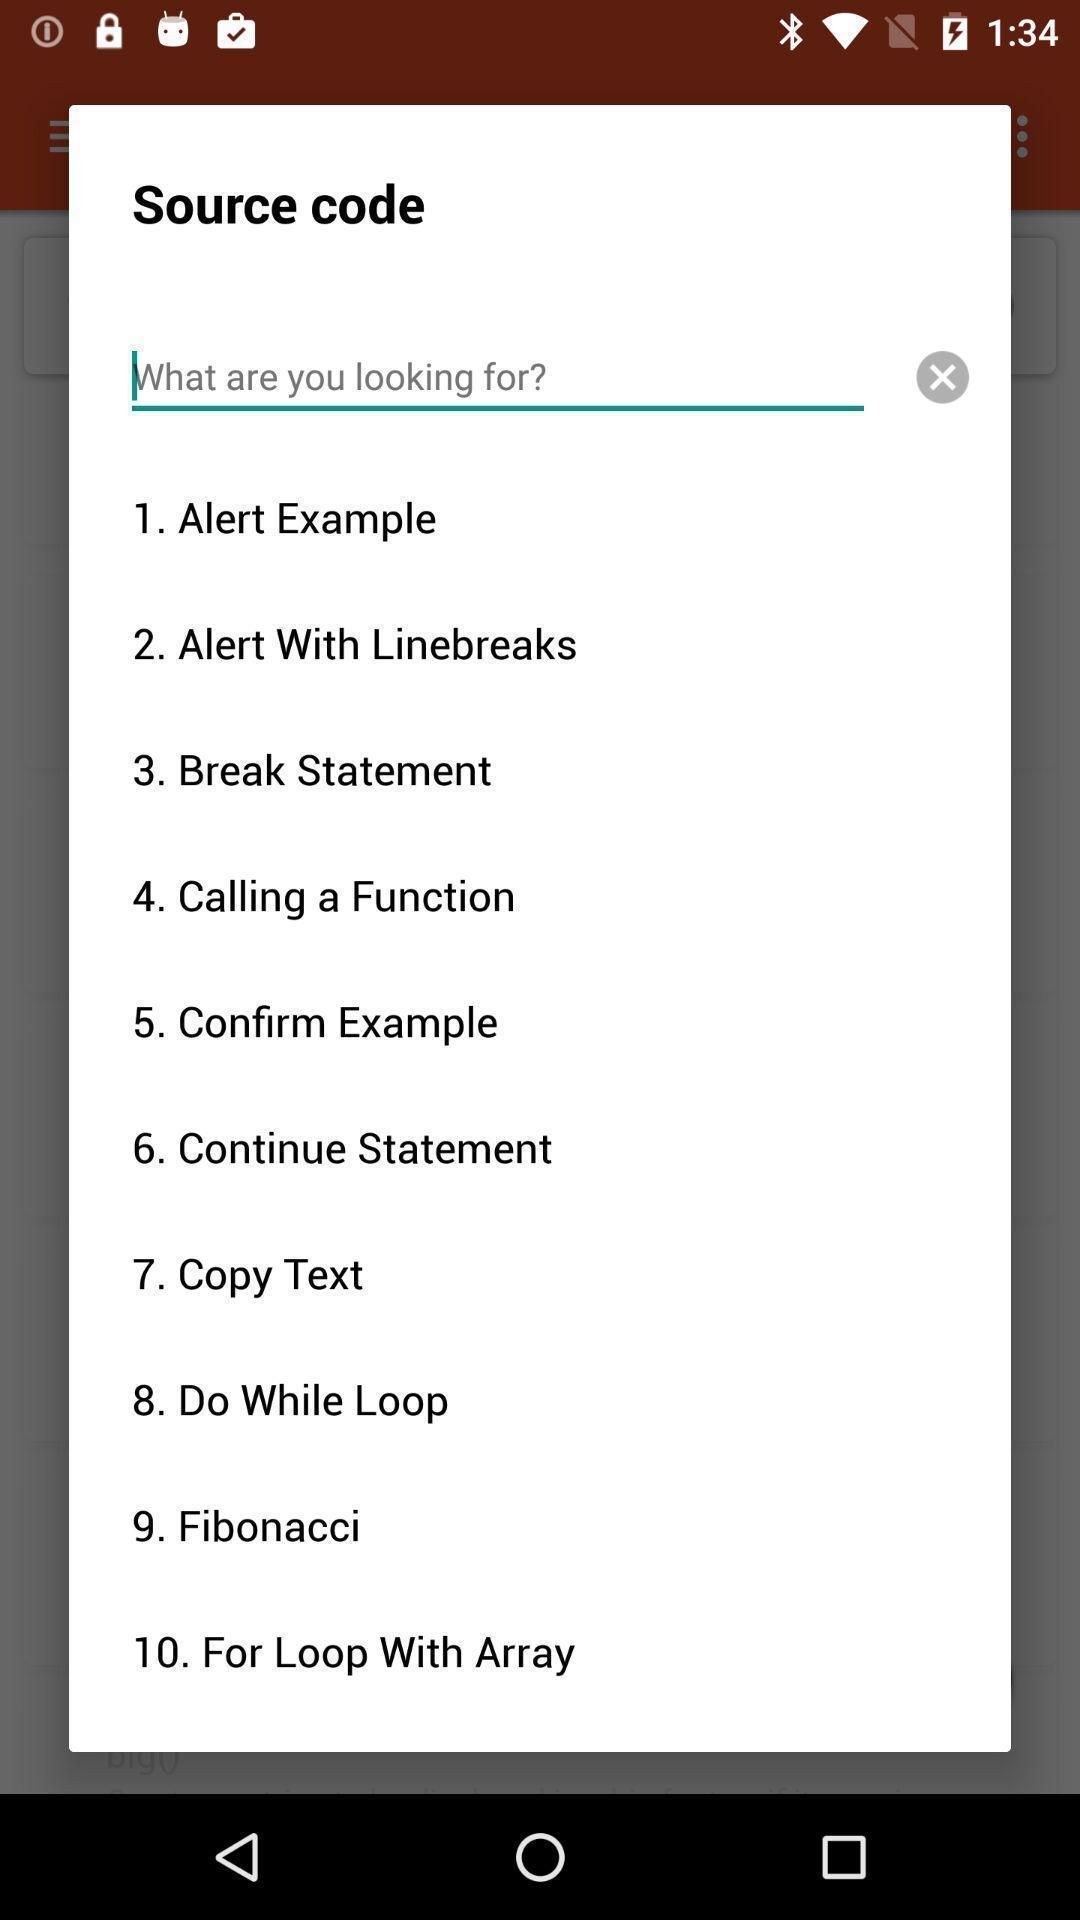Describe this image in words. Pop-up window showing different source code options to search. 